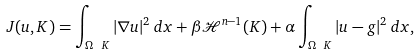<formula> <loc_0><loc_0><loc_500><loc_500>J ( u , K ) = \int _ { \Omega \ K } | \nabla u | ^ { 2 } \, d x + \beta \mathcal { H } ^ { n - 1 } ( K ) + \alpha \int _ { \Omega \ K } | u - g | ^ { 2 } \, d x ,</formula> 